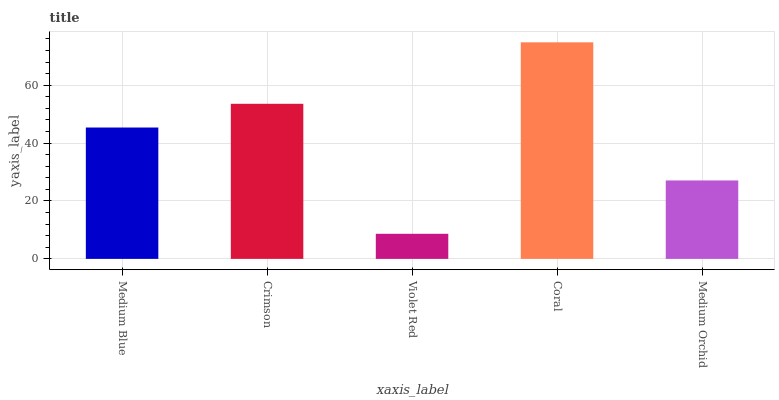Is Crimson the minimum?
Answer yes or no. No. Is Crimson the maximum?
Answer yes or no. No. Is Crimson greater than Medium Blue?
Answer yes or no. Yes. Is Medium Blue less than Crimson?
Answer yes or no. Yes. Is Medium Blue greater than Crimson?
Answer yes or no. No. Is Crimson less than Medium Blue?
Answer yes or no. No. Is Medium Blue the high median?
Answer yes or no. Yes. Is Medium Blue the low median?
Answer yes or no. Yes. Is Medium Orchid the high median?
Answer yes or no. No. Is Medium Orchid the low median?
Answer yes or no. No. 